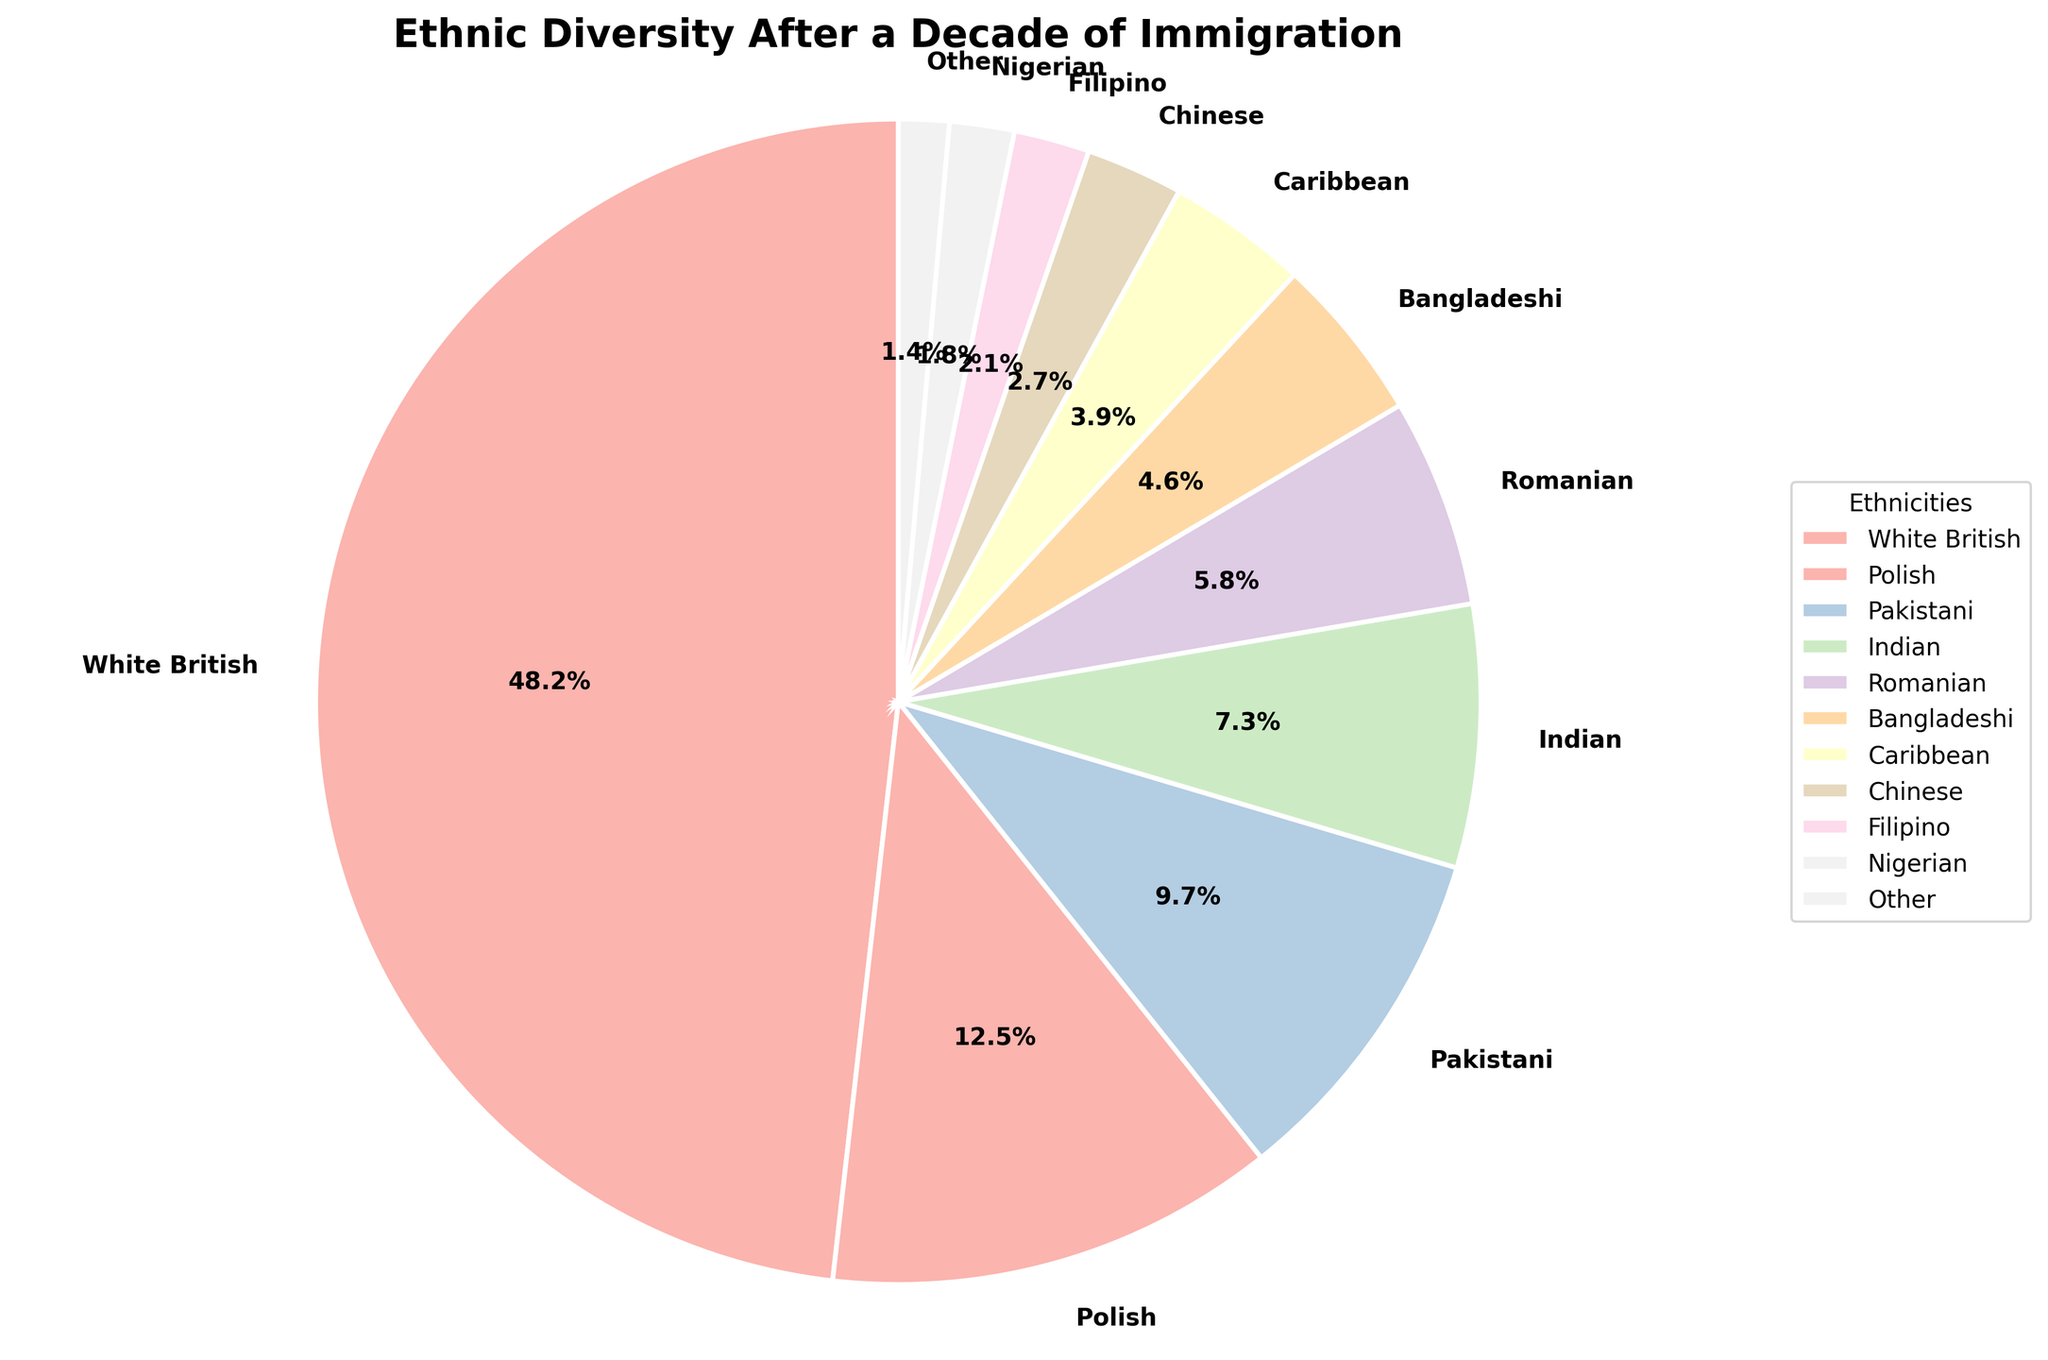What's the largest ethnicity group in the community? The largest ethnicity group is identified by looking at the wedge with the largest percentage value in the pie chart. The "White British" group has the highest percentage at 48.2%.
Answer: White British Which ethnic groups have percentages above 10%? To determine this, look at the percentages associated with each ethnic group and find those that are above 10%. The "White British" with 48.2% and "Polish" with 12.5% are above this threshold.
Answer: White British, Polish What is the combined percentage of the three smallest ethnic groups? Identify the smallest ethnic groups by percentage values: "Filipino" (2.1%), "Nigerian" (1.8%), and "Other" (1.4%). Summing these values gives 2.1% + 1.8% + 1.4% = 5.3%.
Answer: 5.3% Which group forms a larger proportion, Indian or Pakistani? Compare the percentages for "Indian" (7.3%) and "Pakistani" (9.7%). The "Pakistani" group has a higher percentage.
Answer: Pakistani What is the visual color of the Caribbean group in the chart? Locate the wedge labeled "Caribbean" and note its color in the pie chart. For this specific plot using the Pastel1 colormap, the Caribbean wedge is likely a distinguishable pastel color.
Answer: Pastel color (exact shade can vary) How much larger is the percentage of White British compared to Caribbean? Subtract the percentage of the "Caribbean" group (3.9%) from the "White British" group (48.2%). The difference is 48.2% - 3.9% = 44.3%.
Answer: 44.3% What percentage do the Polish and Romanian groups together constitute? Add the percentages for the "Polish" (12.5%) and "Romanian" (5.8%) groups. The combined percentage is 12.5% + 5.8% = 18.3%.
Answer: 18.3% What's the ratio of the percentage of Indian to Filipino groups? Divide the percentage of the "Indian" group (7.3%) by the "Filipino" group (2.1%). The ratio is calculated as 7.3% / 2.1% ≈ 3.48.
Answer: 3.48 If you were to remove the White British group, what percentage would the Pakistani group then constitute of the new total? Without the White British (48.2%), the new total is 100% - 48.2% = 51.8%. The Pakistani percentage 9.7% is then recalculated as (9.7 / 51.8) * 100 ≈ 18.73%.
Answer: 18.73% Which ethnic group has the smallest presence in the community? The ethnic group with the smallest presence is identified by looking at the wedge with the smallest percentage. The "Other" group has the smallest percentage at 1.4%.
Answer: Other 